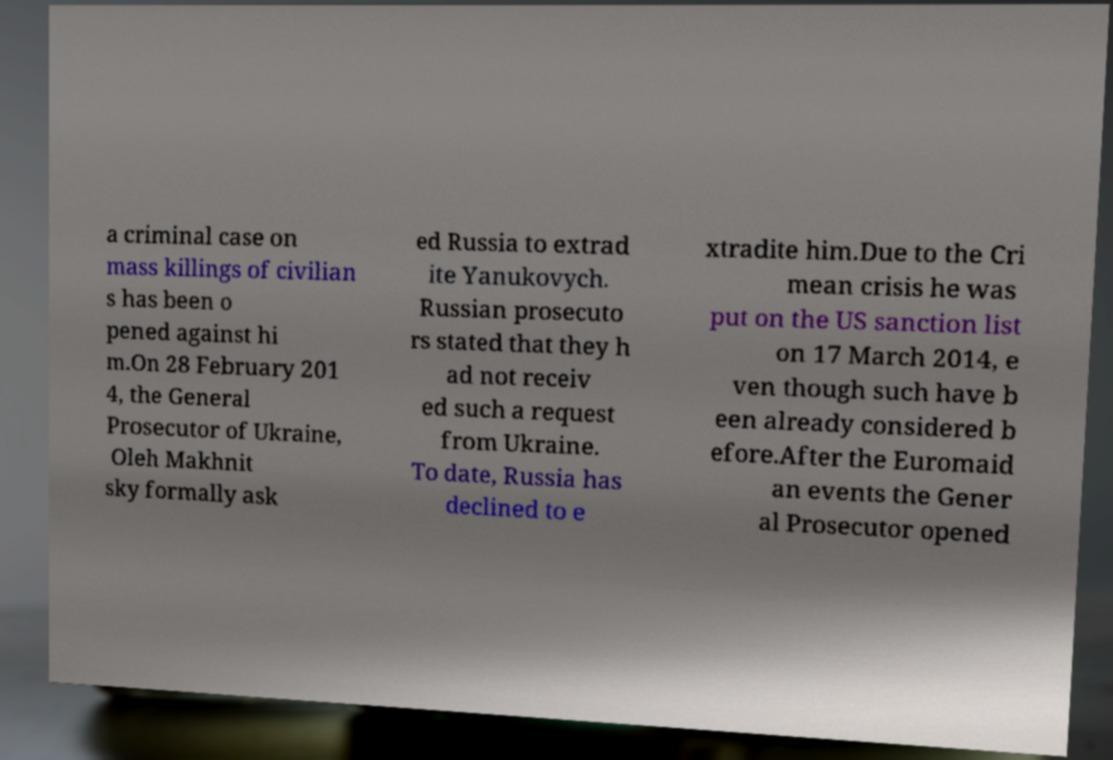What messages or text are displayed in this image? I need them in a readable, typed format. a criminal case on mass killings of civilian s has been o pened against hi m.On 28 February 201 4, the General Prosecutor of Ukraine, Oleh Makhnit sky formally ask ed Russia to extrad ite Yanukovych. Russian prosecuto rs stated that they h ad not receiv ed such a request from Ukraine. To date, Russia has declined to e xtradite him.Due to the Cri mean crisis he was put on the US sanction list on 17 March 2014, e ven though such have b een already considered b efore.After the Euromaid an events the Gener al Prosecutor opened 